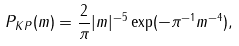<formula> <loc_0><loc_0><loc_500><loc_500>P _ { K P } ( m ) = \frac { 2 } { \pi } | m | ^ { - 5 } \exp ( - \pi ^ { - 1 } m ^ { - 4 } ) ,</formula> 